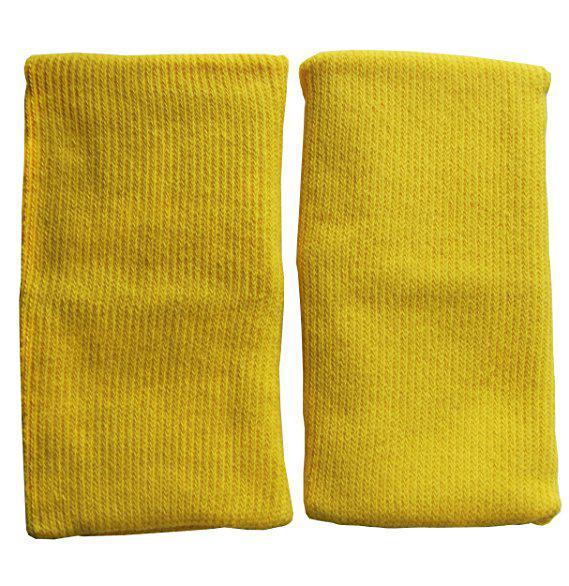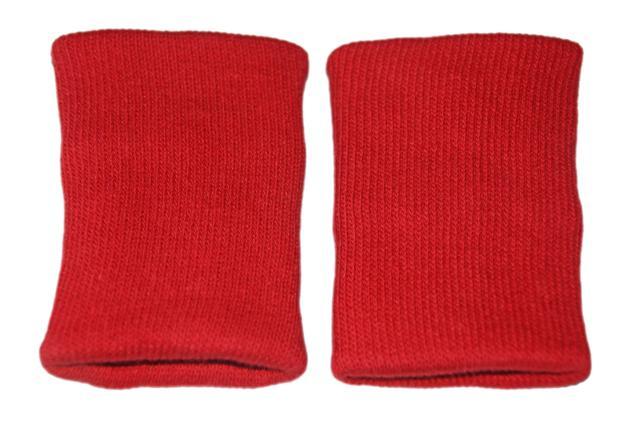The first image is the image on the left, the second image is the image on the right. Given the left and right images, does the statement "The left and right image contains the same number of soft knit wrist guards." hold true? Answer yes or no. Yes. The first image is the image on the left, the second image is the image on the right. Evaluate the accuracy of this statement regarding the images: "One image shows a pair of toddler knees kneeling on a wood floor and wearing colored knee pads with paw prints on them.". Is it true? Answer yes or no. No. 